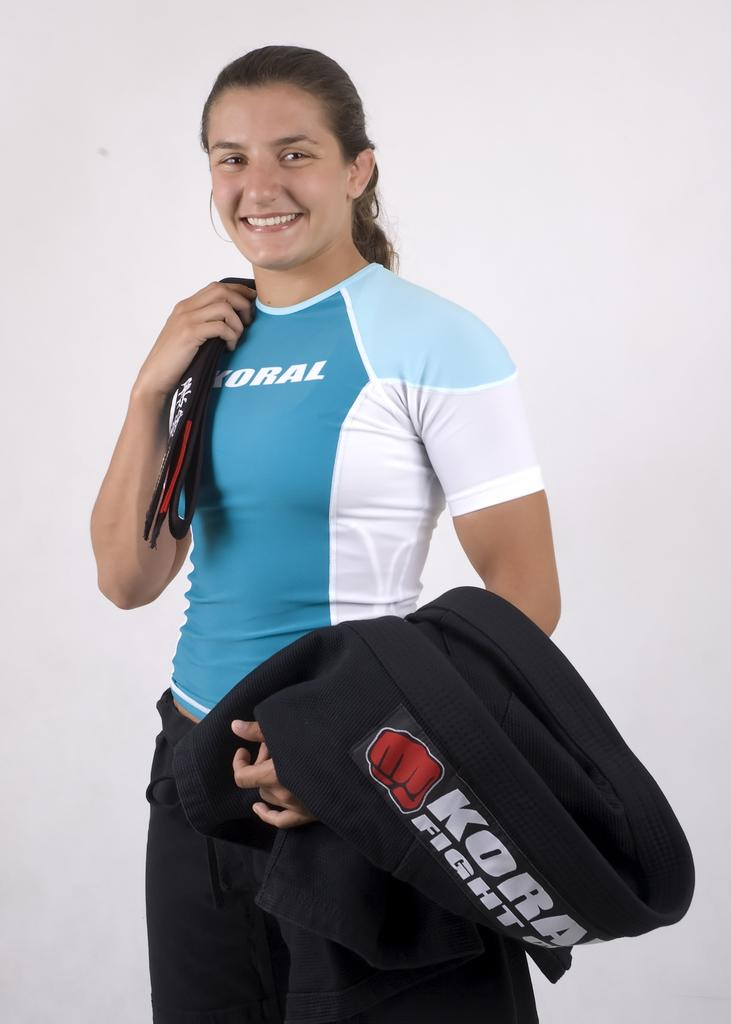<image>
Write a terse but informative summary of the picture. A woman is holding a jacket with the letter k on it. 